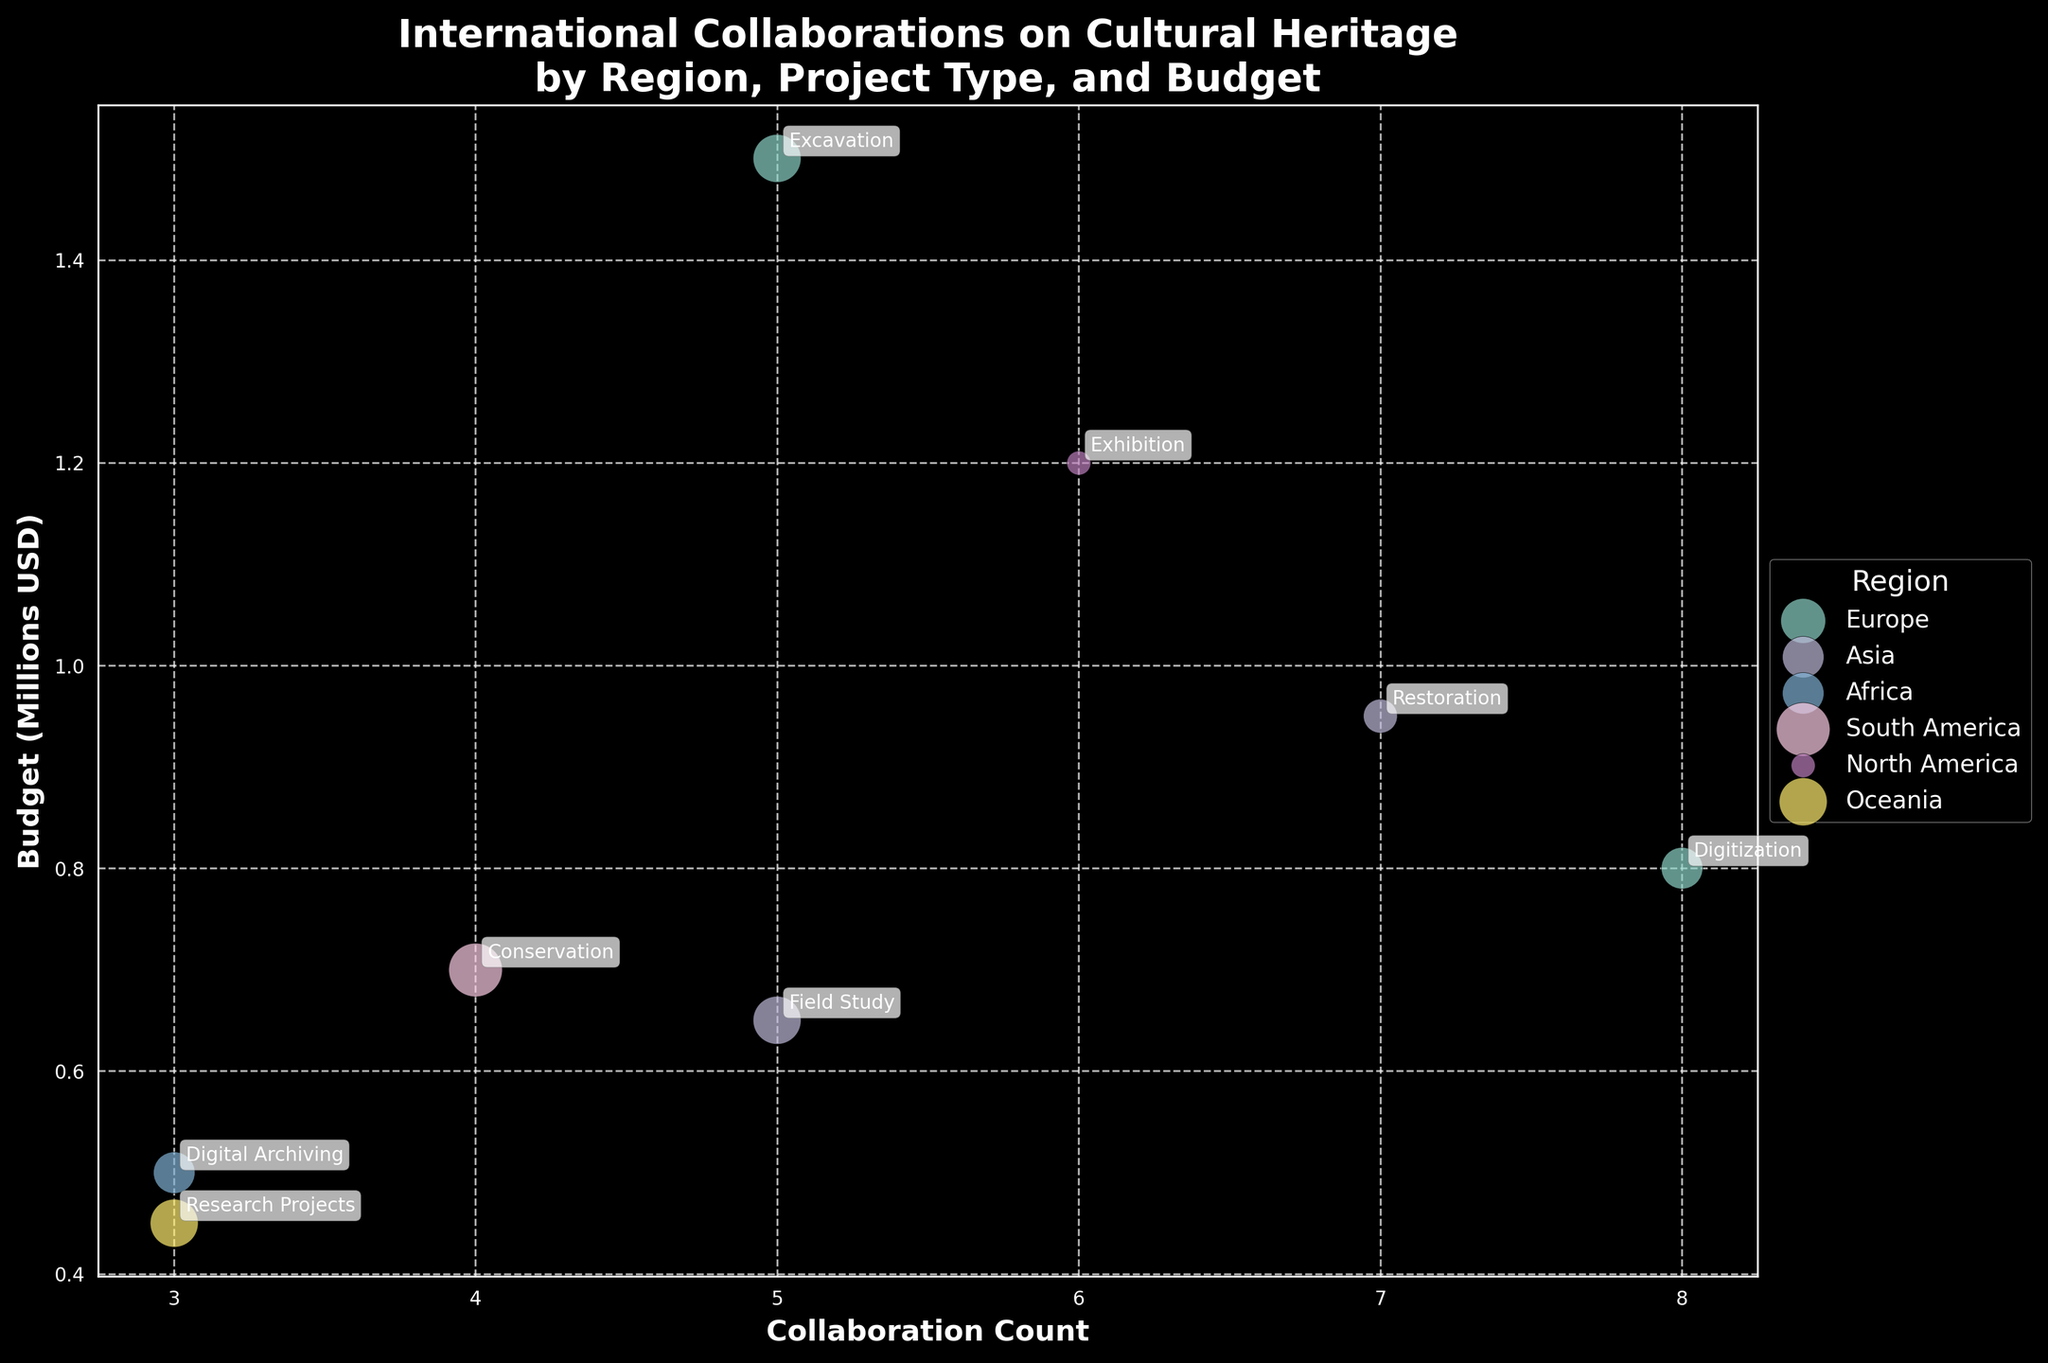What is the title of the plot? The title is displayed at the top of the plot.
Answer: International Collaborations on Cultural Heritage by Region, Project Type, and Budget Which region has the highest bubble size representation for projects done in recent years? The regions are represented by different colors and bubble sizes reflect recent years: larger size means more recent projects. The largest bubble is in Europe from 2021 representing Louvre Museum's project.
Answer: Europe How many collaboration projects have a budget exceeding 1 million USD? Count the number of bubbles with a y-value above 1 (since the y-axis measures the budget in millions USD). There are two such points: British Museum and Smithsonian Institution.
Answer: 2 Which project type has the highest collaboration count in Asia? Look for annotations within the bubbles in the Asia color grouping, and identify the project with the highest x-value. It is 'Restoration'.
Answer: Restoration What is the total budget (in millions USD) spent on projects in Europe according to the plot? Look for all the bubbles representing Europe and sum their y-values. Total is 1.5 + 0.8 = 2.3 million USD.
Answer: 2.3 million Which region has the most diverse project types? Check each region color and count the different annotations within. Europe and Asia each have two project types but Europe has a slight edge due to complex projects (Excavation, Digitization).
Answer: Europe How does the budget of the project on 'Neolithic Pottery' compare to the budget of the 'Textiles' project? Compare the y-values: the 'Neolithic Pottery' project is in Asia at slightly above 0.6 million USD, and the 'Textiles' project is just below 1 million USD. So, the 'Textiles' project has a higher budget.
Answer: Textiles has a higher budget Which project has the lowest budget and what type of project is it? Look at the smallest y-value on the y-axis and identify the corresponding annotation. The smallest value is for 'Oceanic Artifacts' in Oceania.
Answer: Oceanic Artifacts How many regions have at least one project from the year 2021? Identify bubbles sized relative to the year 2021 and count the unique regions. There are Europe, Asia, Oceania, and Africa.
Answer: 4 